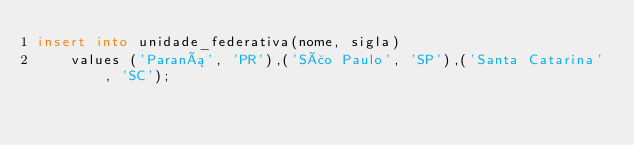<code> <loc_0><loc_0><loc_500><loc_500><_SQL_>insert into unidade_federativa(nome, sigla)
    values ('Paraná', 'PR'),('São Paulo', 'SP'),('Santa Catarina', 'SC');</code> 